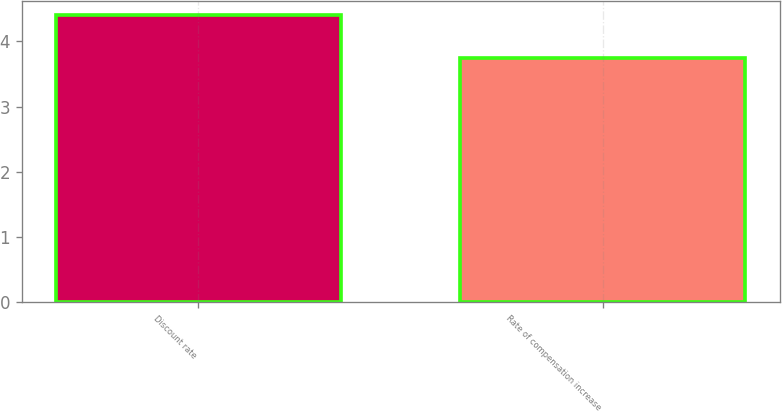Convert chart to OTSL. <chart><loc_0><loc_0><loc_500><loc_500><bar_chart><fcel>Discount rate<fcel>Rate of compensation increase<nl><fcel>4.4<fcel>3.75<nl></chart> 